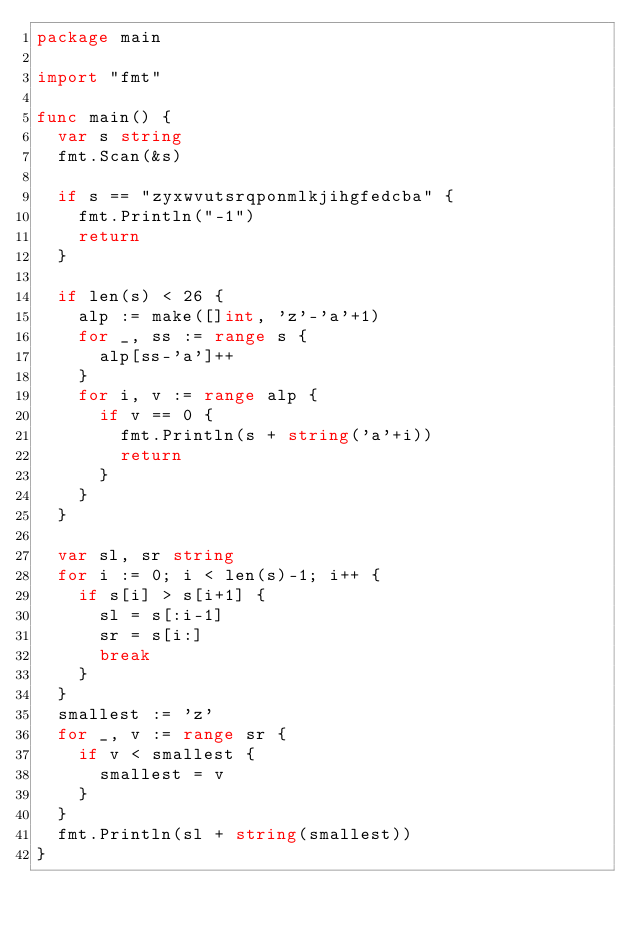Convert code to text. <code><loc_0><loc_0><loc_500><loc_500><_Go_>package main

import "fmt"

func main() {
	var s string
	fmt.Scan(&s)

	if s == "zyxwvutsrqponmlkjihgfedcba" {
		fmt.Println("-1")
		return
	}

	if len(s) < 26 {
		alp := make([]int, 'z'-'a'+1)
		for _, ss := range s {
			alp[ss-'a']++
		}
		for i, v := range alp {
			if v == 0 {
				fmt.Println(s + string('a'+i))
				return
			}
		}
	}

	var sl, sr string
	for i := 0; i < len(s)-1; i++ {
		if s[i] > s[i+1] {
			sl = s[:i-1]
			sr = s[i:]
			break
		}
	}
	smallest := 'z'
	for _, v := range sr {
		if v < smallest {
			smallest = v
		}
	}
	fmt.Println(sl + string(smallest))
}
</code> 